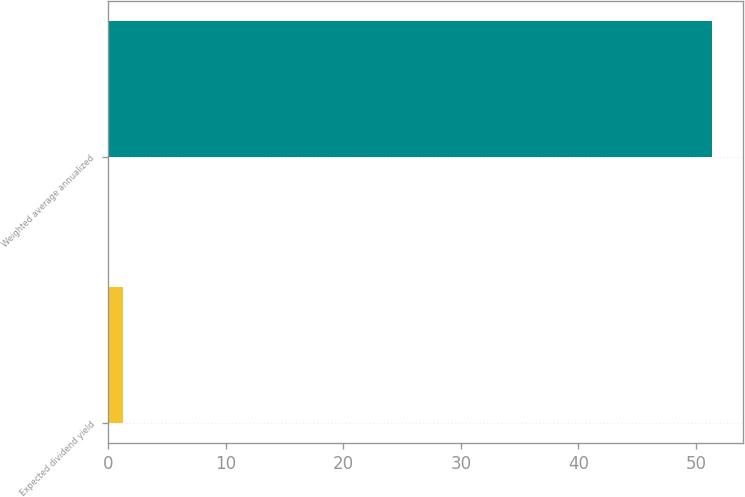Convert chart. <chart><loc_0><loc_0><loc_500><loc_500><bar_chart><fcel>Expected dividend yield<fcel>Weighted average annualized<nl><fcel>1.3<fcel>51.4<nl></chart> 